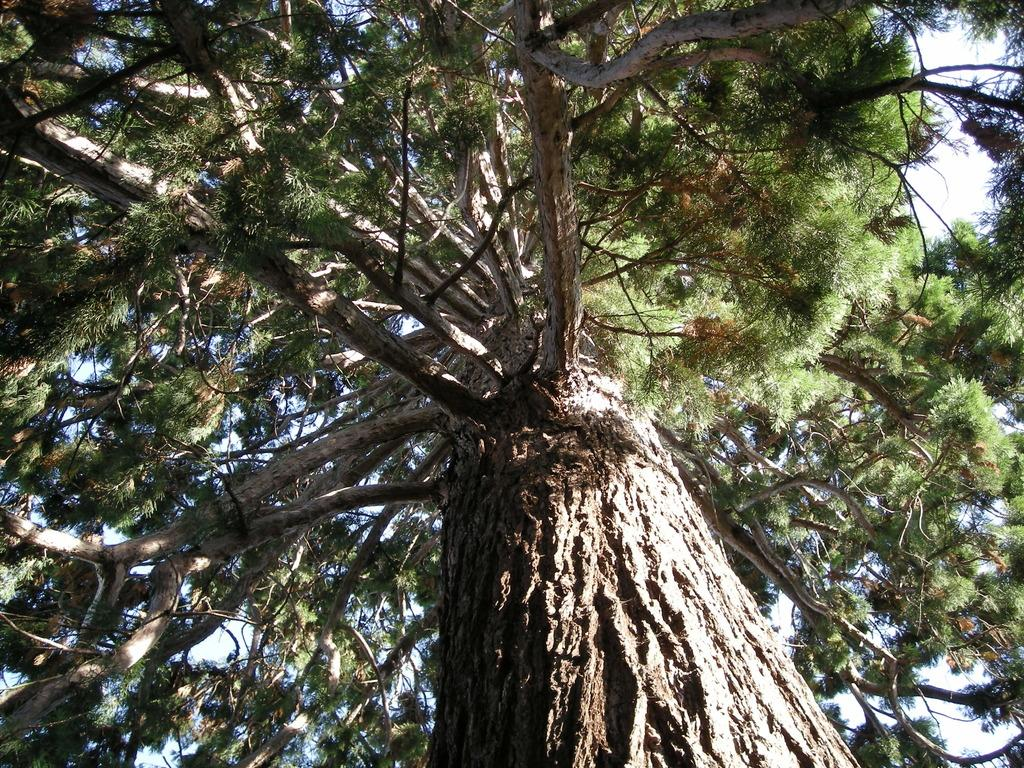What type of plant can be seen in the image? There is a tree in the image. What are the main features of the tree? The tree has branches and leaves. What part of the tree is visible in the image? There is a tree trunk visible in the image. What type of writer can be seen sitting under the tree in the image? There is no writer present in the image; it only features a tree with branches, leaves, and a trunk. 